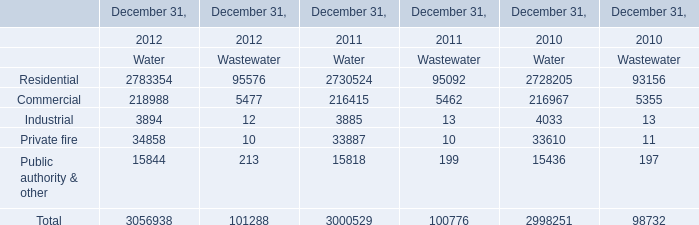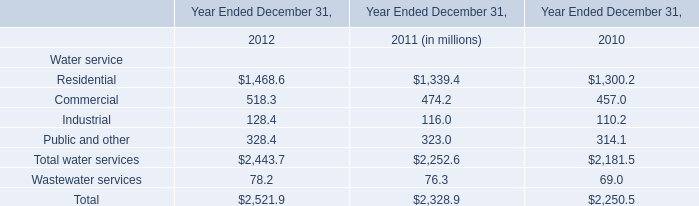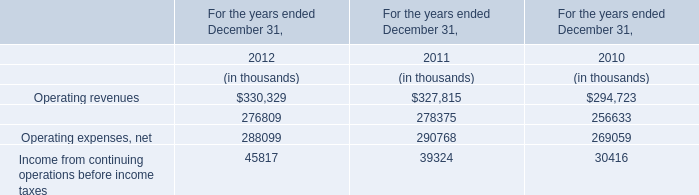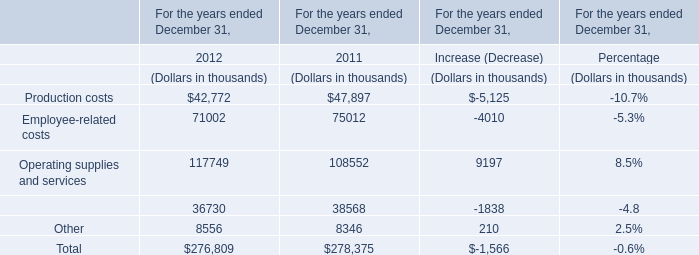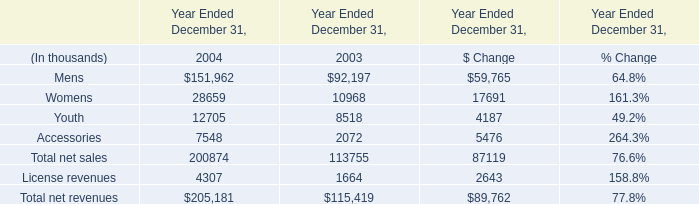What's the average of production costs and employee-related costs in 2012? (in thousand) 
Computations: ((42772 + 71002) / 2)
Answer: 56887.0. 